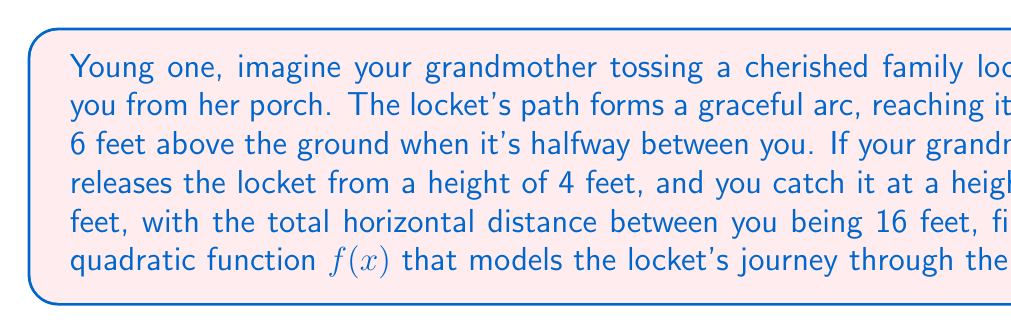Help me with this question. Let's approach this step-by-step, drawing on the wisdom of generations:

1) The general form of a quadratic function is $f(x) = ax^2 + bx + c$.

2) We know three points on this parabola:
   - Start: (0, 4)
   - Peak: (8, 6)
   - End: (16, 5)

3) Using the vertex form of a quadratic function: $f(x) = a(x-h)^2 + k$
   Where (h,k) is the vertex, which is the peak point (8, 6).

4) Substituting the vertex:
   $f(x) = a(x-8)^2 + 6$

5) Now, let's use the starting point (0, 4) to find $a$:
   $4 = a(0-8)^2 + 6$
   $4 = 64a + 6$
   $-2 = 64a$
   $a = -\frac{1}{32}$

6) Therefore, our quadratic function is:
   $f(x) = -\frac{1}{32}(x-8)^2 + 6$

7) Expanding this:
   $f(x) = -\frac{1}{32}(x^2 - 16x + 64) + 6$
   $f(x) = -\frac{1}{32}x^2 + \frac{1}{2}x - 2 + 6$
   $f(x) = -\frac{1}{32}x^2 + \frac{1}{2}x + 4$

8) This function satisfies all given conditions:
   $f(0) = 4$, $f(8) = 6$, and $f(16) = 5$
Answer: $f(x) = -\frac{1}{32}x^2 + \frac{1}{2}x + 4$ 